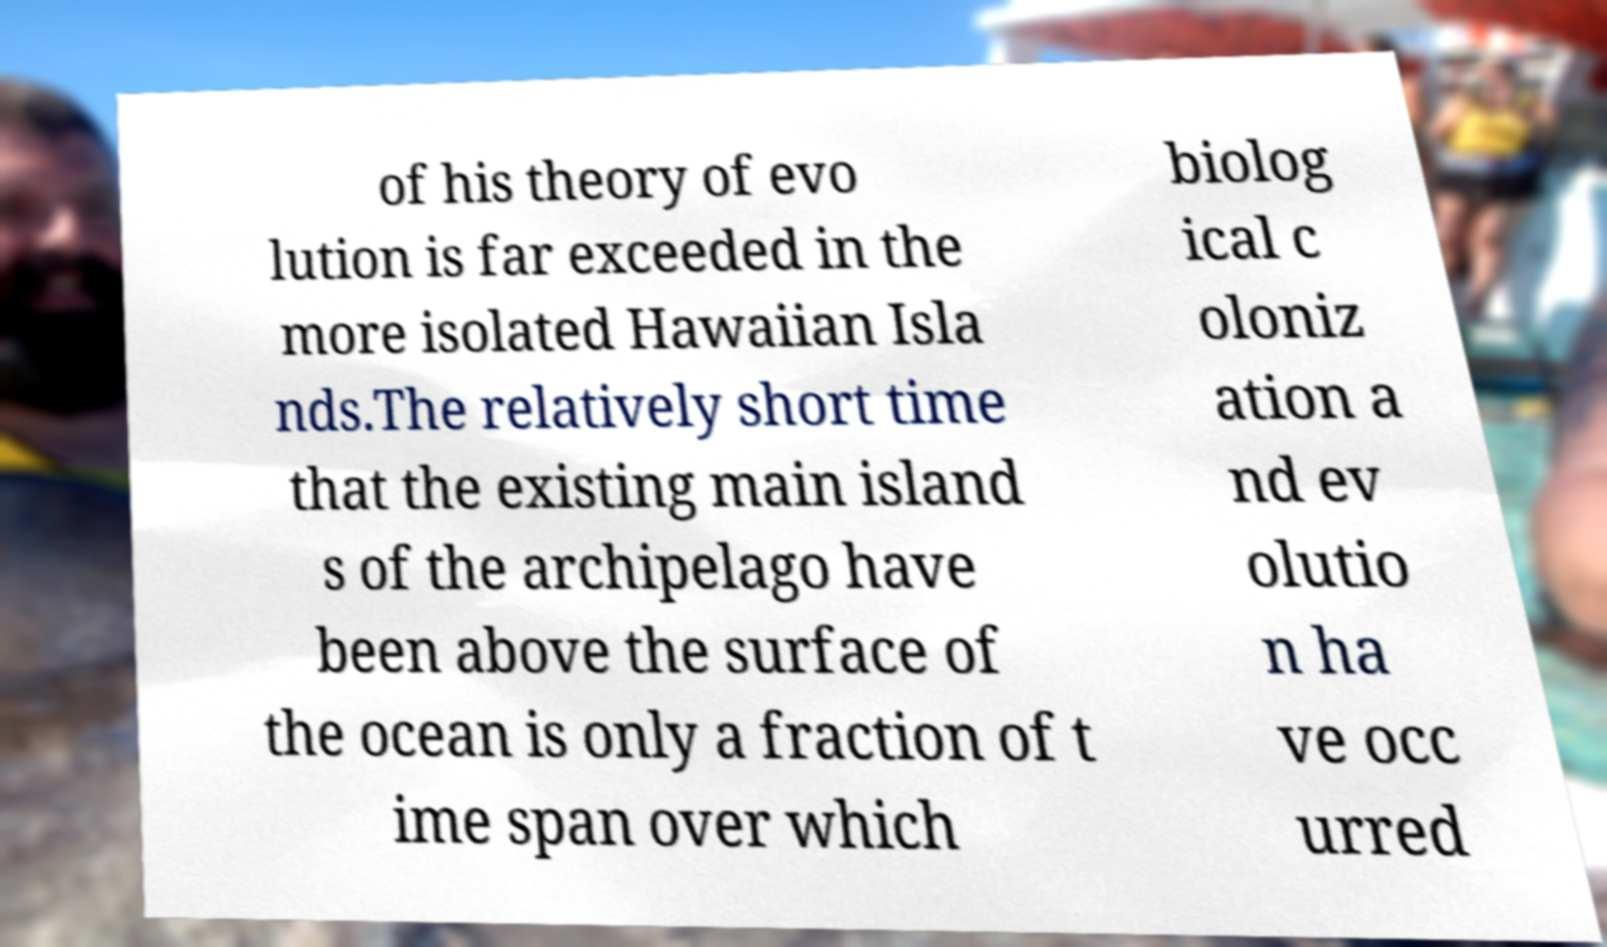Could you extract and type out the text from this image? of his theory of evo lution is far exceeded in the more isolated Hawaiian Isla nds.The relatively short time that the existing main island s of the archipelago have been above the surface of the ocean is only a fraction of t ime span over which biolog ical c oloniz ation a nd ev olutio n ha ve occ urred 